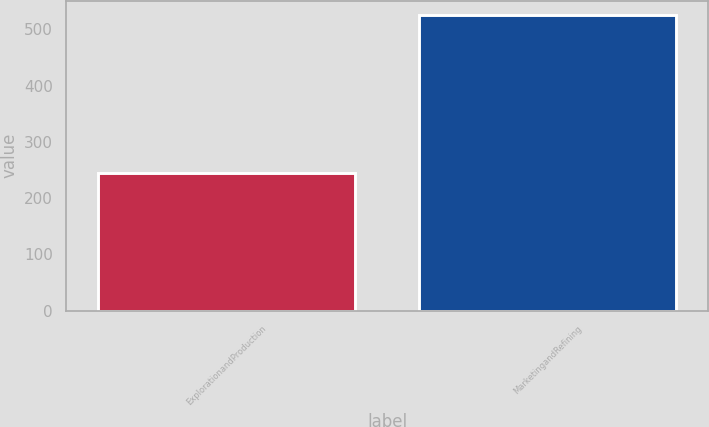Convert chart to OTSL. <chart><loc_0><loc_0><loc_500><loc_500><bar_chart><fcel>ExplorationandProduction<fcel>MarketingandRefining<nl><fcel>244<fcel>525<nl></chart> 